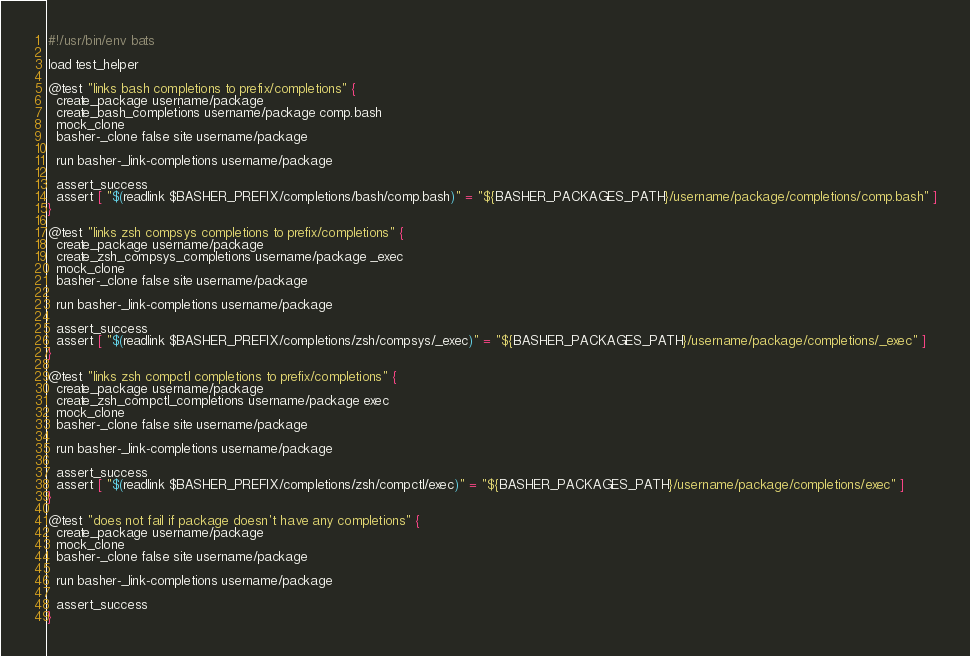<code> <loc_0><loc_0><loc_500><loc_500><_Bash_>#!/usr/bin/env bats

load test_helper

@test "links bash completions to prefix/completions" {
  create_package username/package
  create_bash_completions username/package comp.bash
  mock_clone
  basher-_clone false site username/package

  run basher-_link-completions username/package

  assert_success
  assert [ "$(readlink $BASHER_PREFIX/completions/bash/comp.bash)" = "${BASHER_PACKAGES_PATH}/username/package/completions/comp.bash" ]
}

@test "links zsh compsys completions to prefix/completions" {
  create_package username/package
  create_zsh_compsys_completions username/package _exec
  mock_clone
  basher-_clone false site username/package

  run basher-_link-completions username/package

  assert_success
  assert [ "$(readlink $BASHER_PREFIX/completions/zsh/compsys/_exec)" = "${BASHER_PACKAGES_PATH}/username/package/completions/_exec" ]
}

@test "links zsh compctl completions to prefix/completions" {
  create_package username/package
  create_zsh_compctl_completions username/package exec
  mock_clone
  basher-_clone false site username/package

  run basher-_link-completions username/package

  assert_success
  assert [ "$(readlink $BASHER_PREFIX/completions/zsh/compctl/exec)" = "${BASHER_PACKAGES_PATH}/username/package/completions/exec" ]
}

@test "does not fail if package doesn't have any completions" {
  create_package username/package
  mock_clone
  basher-_clone false site username/package

  run basher-_link-completions username/package

  assert_success
}
</code> 